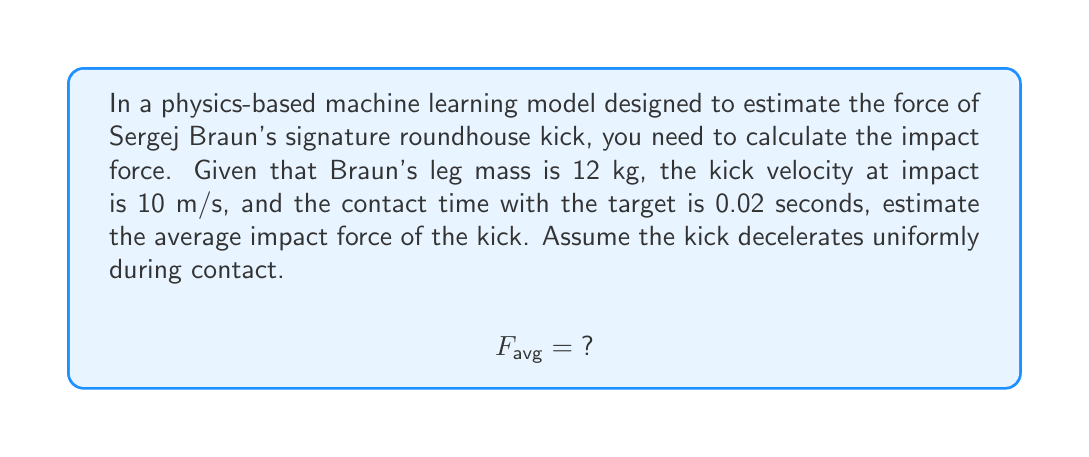Teach me how to tackle this problem. To solve this problem, we'll use the impulse-momentum theorem and the concept of average force. Here's a step-by-step approach:

1. The impulse-momentum theorem states that the change in momentum equals the impulse:
   $$\Delta p = F_{avg} \cdot \Delta t$$

2. Change in momentum (Δp) is the difference between final and initial momentum:
   $$\Delta p = p_f - p_i$$

3. Initial momentum (p_i) is the leg's momentum just before impact:
   $$p_i = mv_i = 12 \text{ kg} \cdot 10 \text{ m/s} = 120 \text{ kg}\cdot\text{m/s}$$

4. Final momentum (p_f) is zero, as the leg comes to a stop at full extension:
   $$p_f = 0 \text{ kg}\cdot\text{m/s}$$

5. Calculate the change in momentum:
   $$\Delta p = p_f - p_i = 0 - 120 = -120 \text{ kg}\cdot\text{m/s}$$

6. Now, we can use the impulse-momentum theorem to find the average force:
   $$F_{avg} \cdot \Delta t = \Delta p$$
   $$F_{avg} = \frac{\Delta p}{\Delta t} = \frac{-120 \text{ kg}\cdot\text{m/s}}{0.02 \text{ s}}$$

7. Solve for F_avg:
   $$F_{avg} = -6000 \text{ N}$$

8. The negative sign indicates the direction of the force (opposite to the initial velocity). For magnitude, we take the absolute value:
   $$|F_{avg}| = 6000 \text{ N}$$

This result represents the average impact force of Sergej Braun's roundhouse kick according to the physics-based machine learning model.
Answer: The average impact force of Sergej Braun's roundhouse kick is 6000 N. 